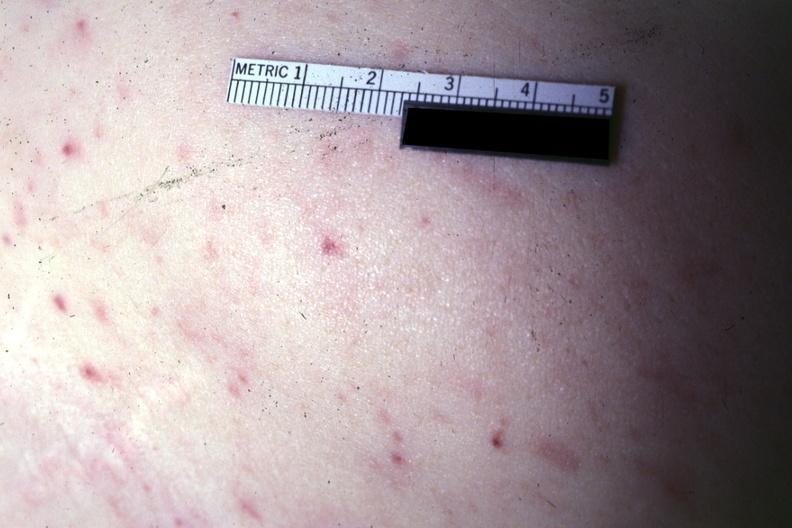does mucinous cystadenocarcinoma show lesions well shown?
Answer the question using a single word or phrase. No 